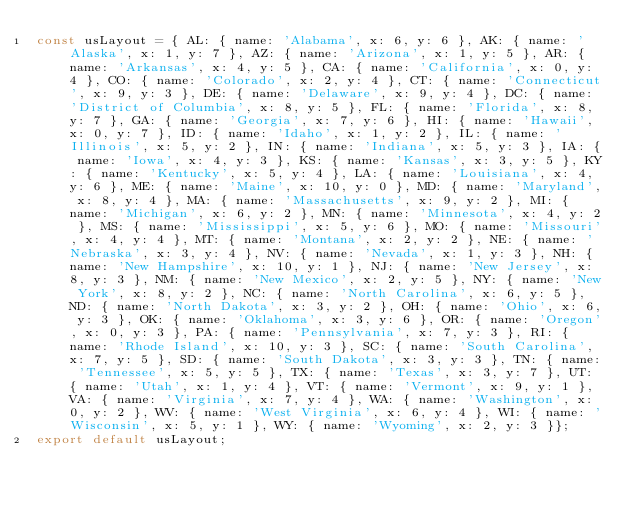Convert code to text. <code><loc_0><loc_0><loc_500><loc_500><_JavaScript_>const usLayout = { AL: { name: 'Alabama', x: 6, y: 6 }, AK: { name: 'Alaska', x: 1, y: 7 }, AZ: { name: 'Arizona', x: 1, y: 5 }, AR: { name: 'Arkansas', x: 4, y: 5 }, CA: { name: 'California', x: 0, y: 4 }, CO: { name: 'Colorado', x: 2, y: 4 }, CT: { name: 'Connecticut', x: 9, y: 3 }, DE: { name: 'Delaware', x: 9, y: 4 }, DC: { name: 'District of Columbia', x: 8, y: 5 }, FL: { name: 'Florida', x: 8, y: 7 }, GA: { name: 'Georgia', x: 7, y: 6 }, HI: { name: 'Hawaii', x: 0, y: 7 }, ID: { name: 'Idaho', x: 1, y: 2 }, IL: { name: 'Illinois', x: 5, y: 2 }, IN: { name: 'Indiana', x: 5, y: 3 }, IA: { name: 'Iowa', x: 4, y: 3 }, KS: { name: 'Kansas', x: 3, y: 5 }, KY: { name: 'Kentucky', x: 5, y: 4 }, LA: { name: 'Louisiana', x: 4, y: 6 }, ME: { name: 'Maine', x: 10, y: 0 }, MD: { name: 'Maryland', x: 8, y: 4 }, MA: { name: 'Massachusetts', x: 9, y: 2 }, MI: { name: 'Michigan', x: 6, y: 2 }, MN: { name: 'Minnesota', x: 4, y: 2 }, MS: { name: 'Mississippi', x: 5, y: 6 }, MO: { name: 'Missouri', x: 4, y: 4 }, MT: { name: 'Montana', x: 2, y: 2 }, NE: { name: 'Nebraska', x: 3, y: 4 }, NV: { name: 'Nevada', x: 1, y: 3 }, NH: { name: 'New Hampshire', x: 10, y: 1 }, NJ: { name: 'New Jersey', x: 8, y: 3 }, NM: { name: 'New Mexico', x: 2, y: 5 }, NY: { name: 'New York', x: 8, y: 2 }, NC: { name: 'North Carolina', x: 6, y: 5 }, ND: { name: 'North Dakota', x: 3, y: 2 }, OH: { name: 'Ohio', x: 6, y: 3 }, OK: { name: 'Oklahoma', x: 3, y: 6 }, OR: { name: 'Oregon', x: 0, y: 3 }, PA: { name: 'Pennsylvania', x: 7, y: 3 }, RI: { name: 'Rhode Island', x: 10, y: 3 }, SC: { name: 'South Carolina', x: 7, y: 5 }, SD: { name: 'South Dakota', x: 3, y: 3 }, TN: { name: 'Tennessee', x: 5, y: 5 }, TX: { name: 'Texas', x: 3, y: 7 }, UT: { name: 'Utah', x: 1, y: 4 }, VT: { name: 'Vermont', x: 9, y: 1 }, VA: { name: 'Virginia', x: 7, y: 4 }, WA: { name: 'Washington', x: 0, y: 2 }, WV: { name: 'West Virginia', x: 6, y: 4 }, WI: { name: 'Wisconsin', x: 5, y: 1 }, WY: { name: 'Wyoming', x: 2, y: 3 }};
export default usLayout;
</code> 